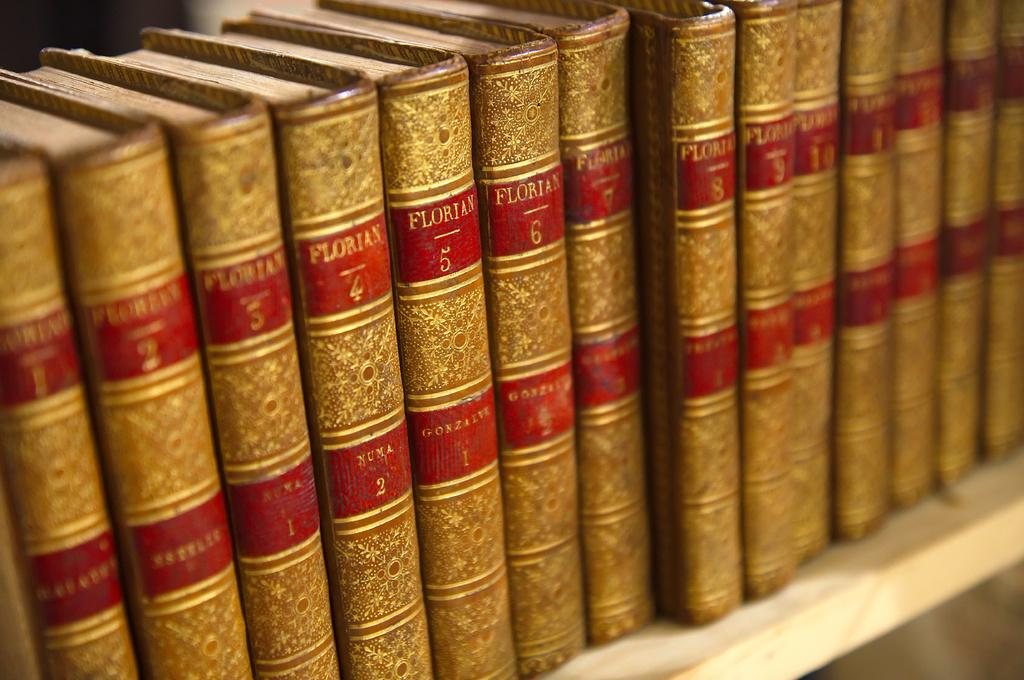<image>
Give a short and clear explanation of the subsequent image. books that say 'floritan' with a number on the side of them 